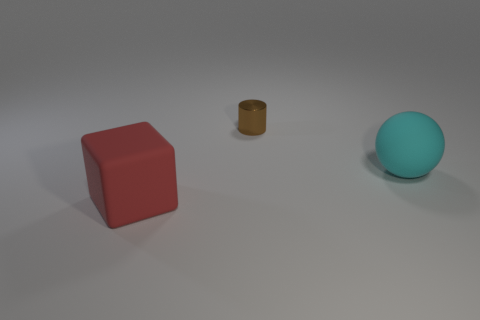Are there more tiny metal cylinders behind the big cyan matte sphere than big gray cylinders?
Your answer should be very brief. Yes. What material is the large thing that is on the right side of the tiny brown object?
Keep it short and to the point. Rubber. How many other large matte objects have the same shape as the large cyan object?
Your response must be concise. 0. What material is the big object in front of the thing that is on the right side of the metallic thing made of?
Your answer should be compact. Rubber. Is there a large red cube made of the same material as the big cyan thing?
Keep it short and to the point. Yes. What is the shape of the small object?
Offer a very short reply. Cylinder. How many big brown metal objects are there?
Provide a succinct answer. 0. There is a matte object behind the large matte thing that is on the left side of the tiny cylinder; what is its color?
Offer a terse response. Cyan. What color is the thing that is the same size as the red matte cube?
Offer a terse response. Cyan. Is there a big rubber thing?
Your answer should be very brief. Yes. 